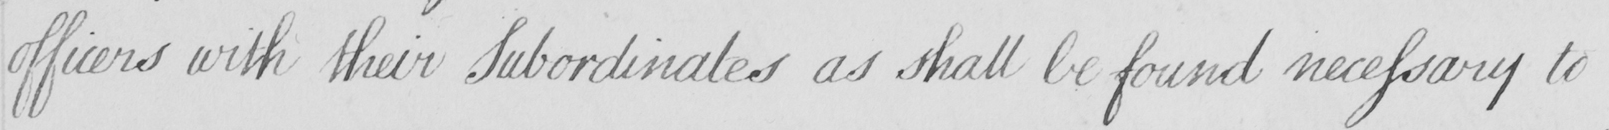Please provide the text content of this handwritten line. officers with their Subordinates as shall be found necessary to 